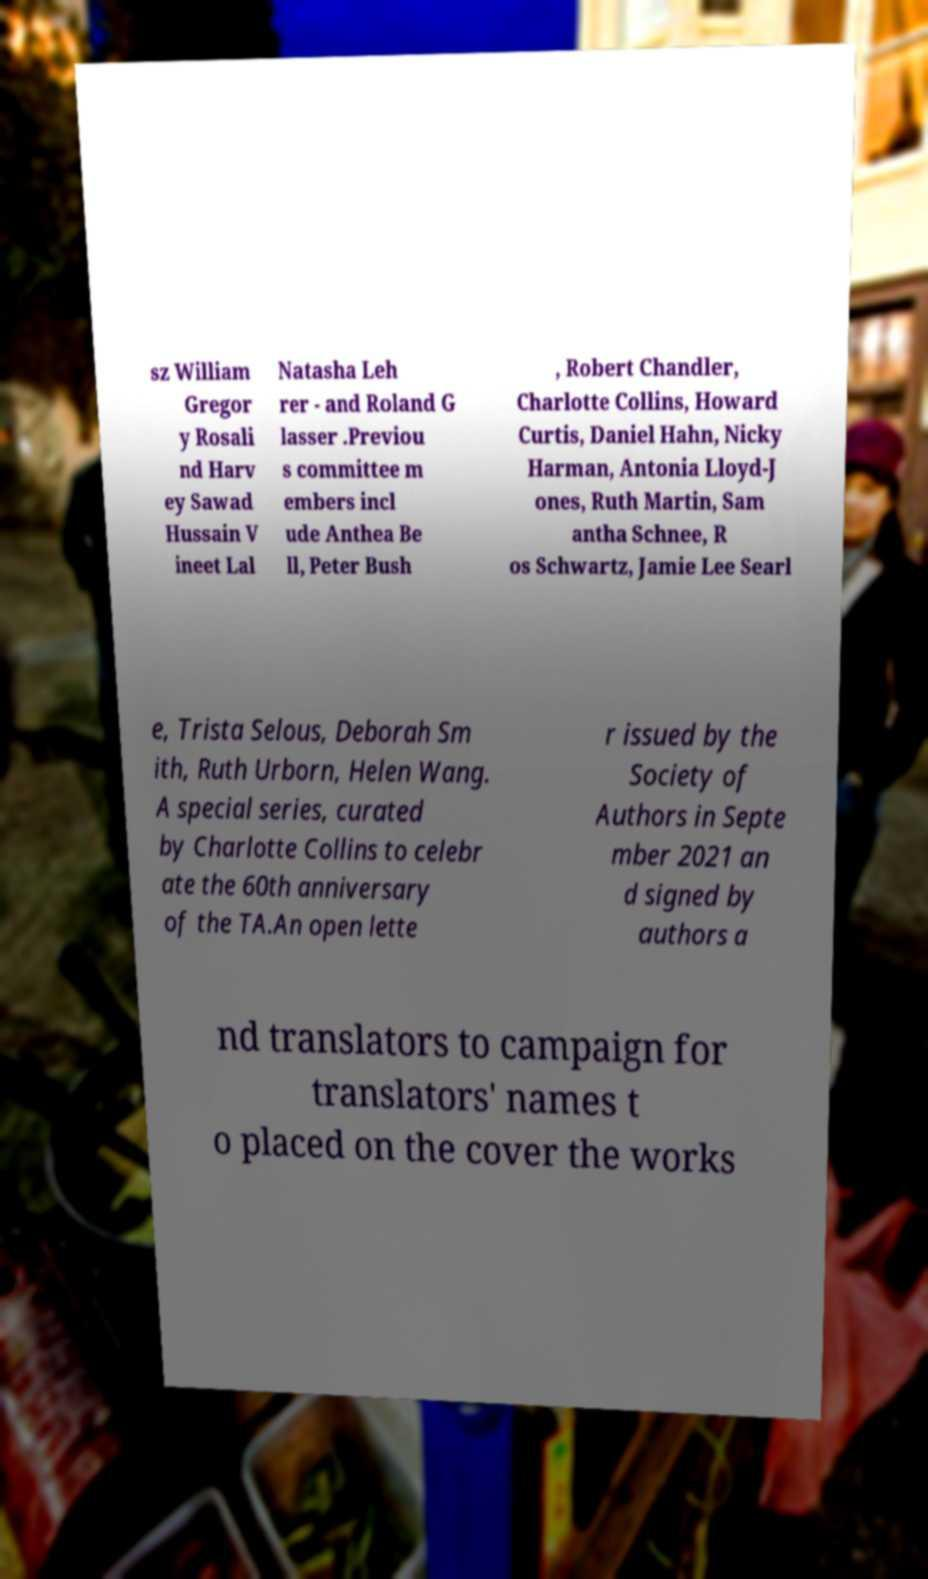Please read and relay the text visible in this image. What does it say? sz William Gregor y Rosali nd Harv ey Sawad Hussain V ineet Lal Natasha Leh rer - and Roland G lasser .Previou s committee m embers incl ude Anthea Be ll, Peter Bush , Robert Chandler, Charlotte Collins, Howard Curtis, Daniel Hahn, Nicky Harman, Antonia Lloyd-J ones, Ruth Martin, Sam antha Schnee, R os Schwartz, Jamie Lee Searl e, Trista Selous, Deborah Sm ith, Ruth Urborn, Helen Wang. A special series, curated by Charlotte Collins to celebr ate the 60th anniversary of the TA.An open lette r issued by the Society of Authors in Septe mber 2021 an d signed by authors a nd translators to campaign for translators' names t o placed on the cover the works 